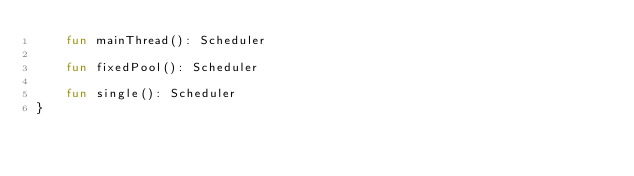Convert code to text. <code><loc_0><loc_0><loc_500><loc_500><_Kotlin_>    fun mainThread(): Scheduler

    fun fixedPool(): Scheduler

    fun single(): Scheduler
}
</code> 